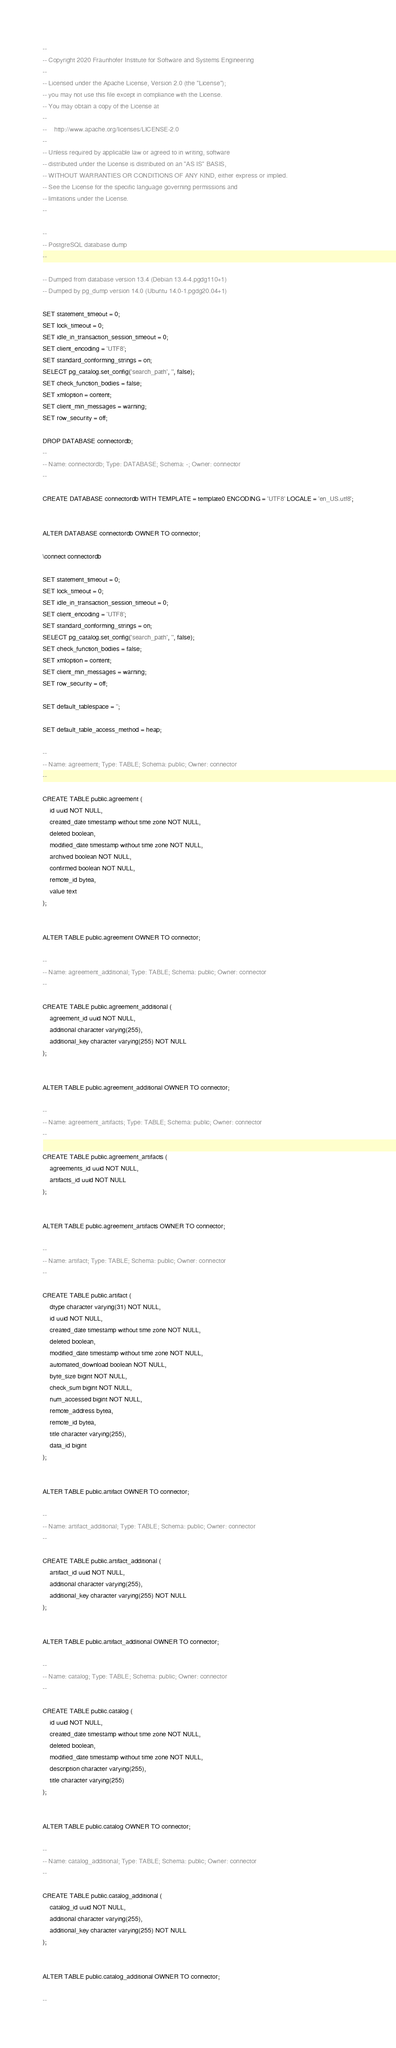Convert code to text. <code><loc_0><loc_0><loc_500><loc_500><_SQL_>--
-- Copyright 2020 Fraunhofer Institute for Software and Systems Engineering
--
-- Licensed under the Apache License, Version 2.0 (the "License");
-- you may not use this file except in compliance with the License.
-- You may obtain a copy of the License at
--
--    http://www.apache.org/licenses/LICENSE-2.0
--
-- Unless required by applicable law or agreed to in writing, software
-- distributed under the License is distributed on an "AS IS" BASIS,
-- WITHOUT WARRANTIES OR CONDITIONS OF ANY KIND, either express or implied.
-- See the License for the specific language governing permissions and
-- limitations under the License.
--

--
-- PostgreSQL database dump
--

-- Dumped from database version 13.4 (Debian 13.4-4.pgdg110+1)
-- Dumped by pg_dump version 14.0 (Ubuntu 14.0-1.pgdg20.04+1)

SET statement_timeout = 0;
SET lock_timeout = 0;
SET idle_in_transaction_session_timeout = 0;
SET client_encoding = 'UTF8';
SET standard_conforming_strings = on;
SELECT pg_catalog.set_config('search_path', '', false);
SET check_function_bodies = false;
SET xmloption = content;
SET client_min_messages = warning;
SET row_security = off;

DROP DATABASE connectordb;
--
-- Name: connectordb; Type: DATABASE; Schema: -; Owner: connector
--

CREATE DATABASE connectordb WITH TEMPLATE = template0 ENCODING = 'UTF8' LOCALE = 'en_US.utf8';


ALTER DATABASE connectordb OWNER TO connector;

\connect connectordb

SET statement_timeout = 0;
SET lock_timeout = 0;
SET idle_in_transaction_session_timeout = 0;
SET client_encoding = 'UTF8';
SET standard_conforming_strings = on;
SELECT pg_catalog.set_config('search_path', '', false);
SET check_function_bodies = false;
SET xmloption = content;
SET client_min_messages = warning;
SET row_security = off;

SET default_tablespace = '';

SET default_table_access_method = heap;

--
-- Name: agreement; Type: TABLE; Schema: public; Owner: connector
--

CREATE TABLE public.agreement (
    id uuid NOT NULL,
    created_date timestamp without time zone NOT NULL,
    deleted boolean,
    modified_date timestamp without time zone NOT NULL,
    archived boolean NOT NULL,
    confirmed boolean NOT NULL,
    remote_id bytea,
    value text
);


ALTER TABLE public.agreement OWNER TO connector;

--
-- Name: agreement_additional; Type: TABLE; Schema: public; Owner: connector
--

CREATE TABLE public.agreement_additional (
    agreement_id uuid NOT NULL,
    additional character varying(255),
    additional_key character varying(255) NOT NULL
);


ALTER TABLE public.agreement_additional OWNER TO connector;

--
-- Name: agreement_artifacts; Type: TABLE; Schema: public; Owner: connector
--

CREATE TABLE public.agreement_artifacts (
    agreements_id uuid NOT NULL,
    artifacts_id uuid NOT NULL
);


ALTER TABLE public.agreement_artifacts OWNER TO connector;

--
-- Name: artifact; Type: TABLE; Schema: public; Owner: connector
--

CREATE TABLE public.artifact (
    dtype character varying(31) NOT NULL,
    id uuid NOT NULL,
    created_date timestamp without time zone NOT NULL,
    deleted boolean,
    modified_date timestamp without time zone NOT NULL,
    automated_download boolean NOT NULL,
    byte_size bigint NOT NULL,
    check_sum bigint NOT NULL,
    num_accessed bigint NOT NULL,
    remote_address bytea,
    remote_id bytea,
    title character varying(255),
    data_id bigint
);


ALTER TABLE public.artifact OWNER TO connector;

--
-- Name: artifact_additional; Type: TABLE; Schema: public; Owner: connector
--

CREATE TABLE public.artifact_additional (
    artifact_id uuid NOT NULL,
    additional character varying(255),
    additional_key character varying(255) NOT NULL
);


ALTER TABLE public.artifact_additional OWNER TO connector;

--
-- Name: catalog; Type: TABLE; Schema: public; Owner: connector
--

CREATE TABLE public.catalog (
    id uuid NOT NULL,
    created_date timestamp without time zone NOT NULL,
    deleted boolean,
    modified_date timestamp without time zone NOT NULL,
    description character varying(255),
    title character varying(255)
);


ALTER TABLE public.catalog OWNER TO connector;

--
-- Name: catalog_additional; Type: TABLE; Schema: public; Owner: connector
--

CREATE TABLE public.catalog_additional (
    catalog_id uuid NOT NULL,
    additional character varying(255),
    additional_key character varying(255) NOT NULL
);


ALTER TABLE public.catalog_additional OWNER TO connector;

--</code> 